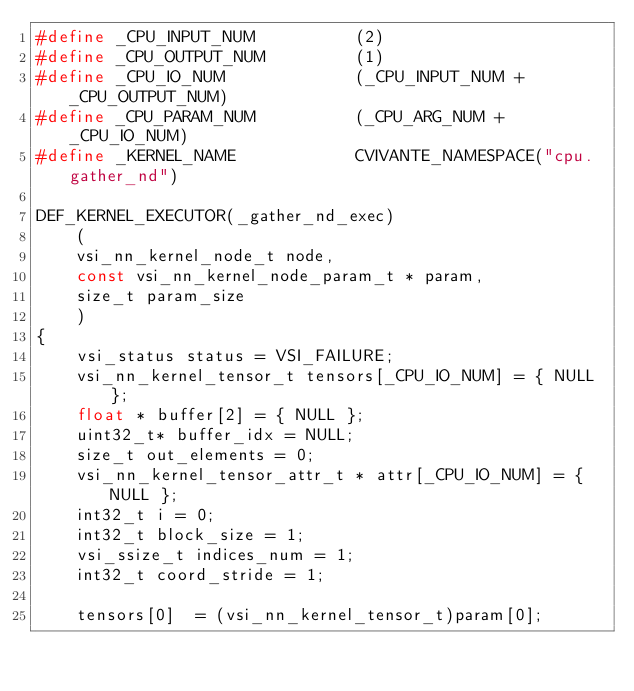Convert code to text. <code><loc_0><loc_0><loc_500><loc_500><_C_>#define _CPU_INPUT_NUM          (2)
#define _CPU_OUTPUT_NUM         (1)
#define _CPU_IO_NUM             (_CPU_INPUT_NUM + _CPU_OUTPUT_NUM)
#define _CPU_PARAM_NUM          (_CPU_ARG_NUM + _CPU_IO_NUM)
#define _KERNEL_NAME            CVIVANTE_NAMESPACE("cpu.gather_nd")

DEF_KERNEL_EXECUTOR(_gather_nd_exec)
    (
    vsi_nn_kernel_node_t node,
    const vsi_nn_kernel_node_param_t * param,
    size_t param_size
    )
{
    vsi_status status = VSI_FAILURE;
    vsi_nn_kernel_tensor_t tensors[_CPU_IO_NUM] = { NULL };
    float * buffer[2] = { NULL };
    uint32_t* buffer_idx = NULL;
    size_t out_elements = 0;
    vsi_nn_kernel_tensor_attr_t * attr[_CPU_IO_NUM] = { NULL };
    int32_t i = 0;
    int32_t block_size = 1;
    vsi_ssize_t indices_num = 1;
    int32_t coord_stride = 1;

    tensors[0]  = (vsi_nn_kernel_tensor_t)param[0];</code> 